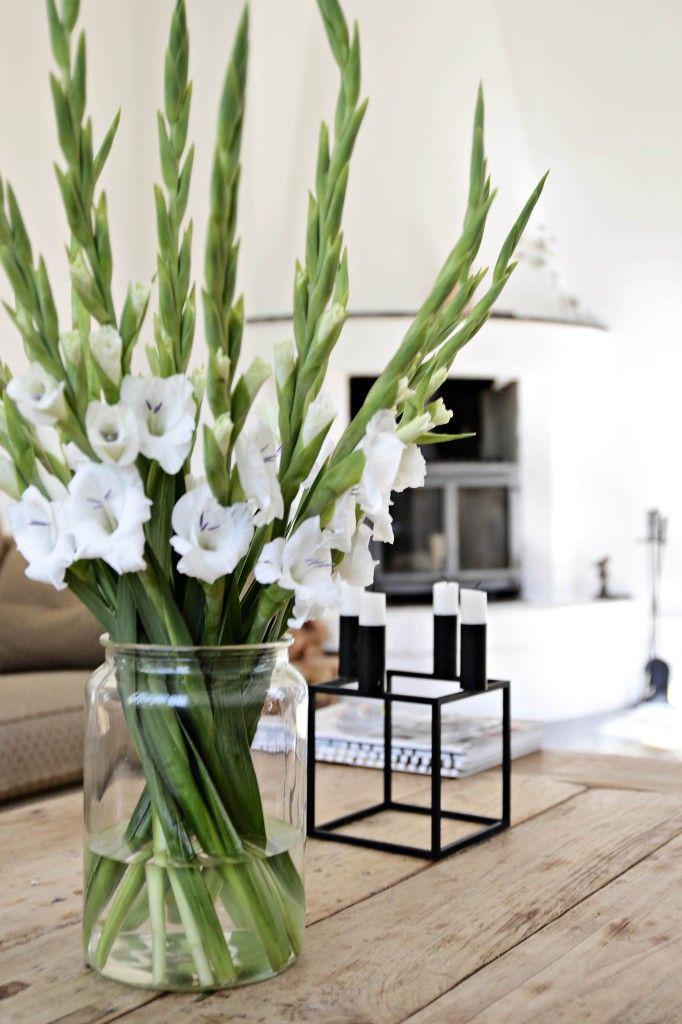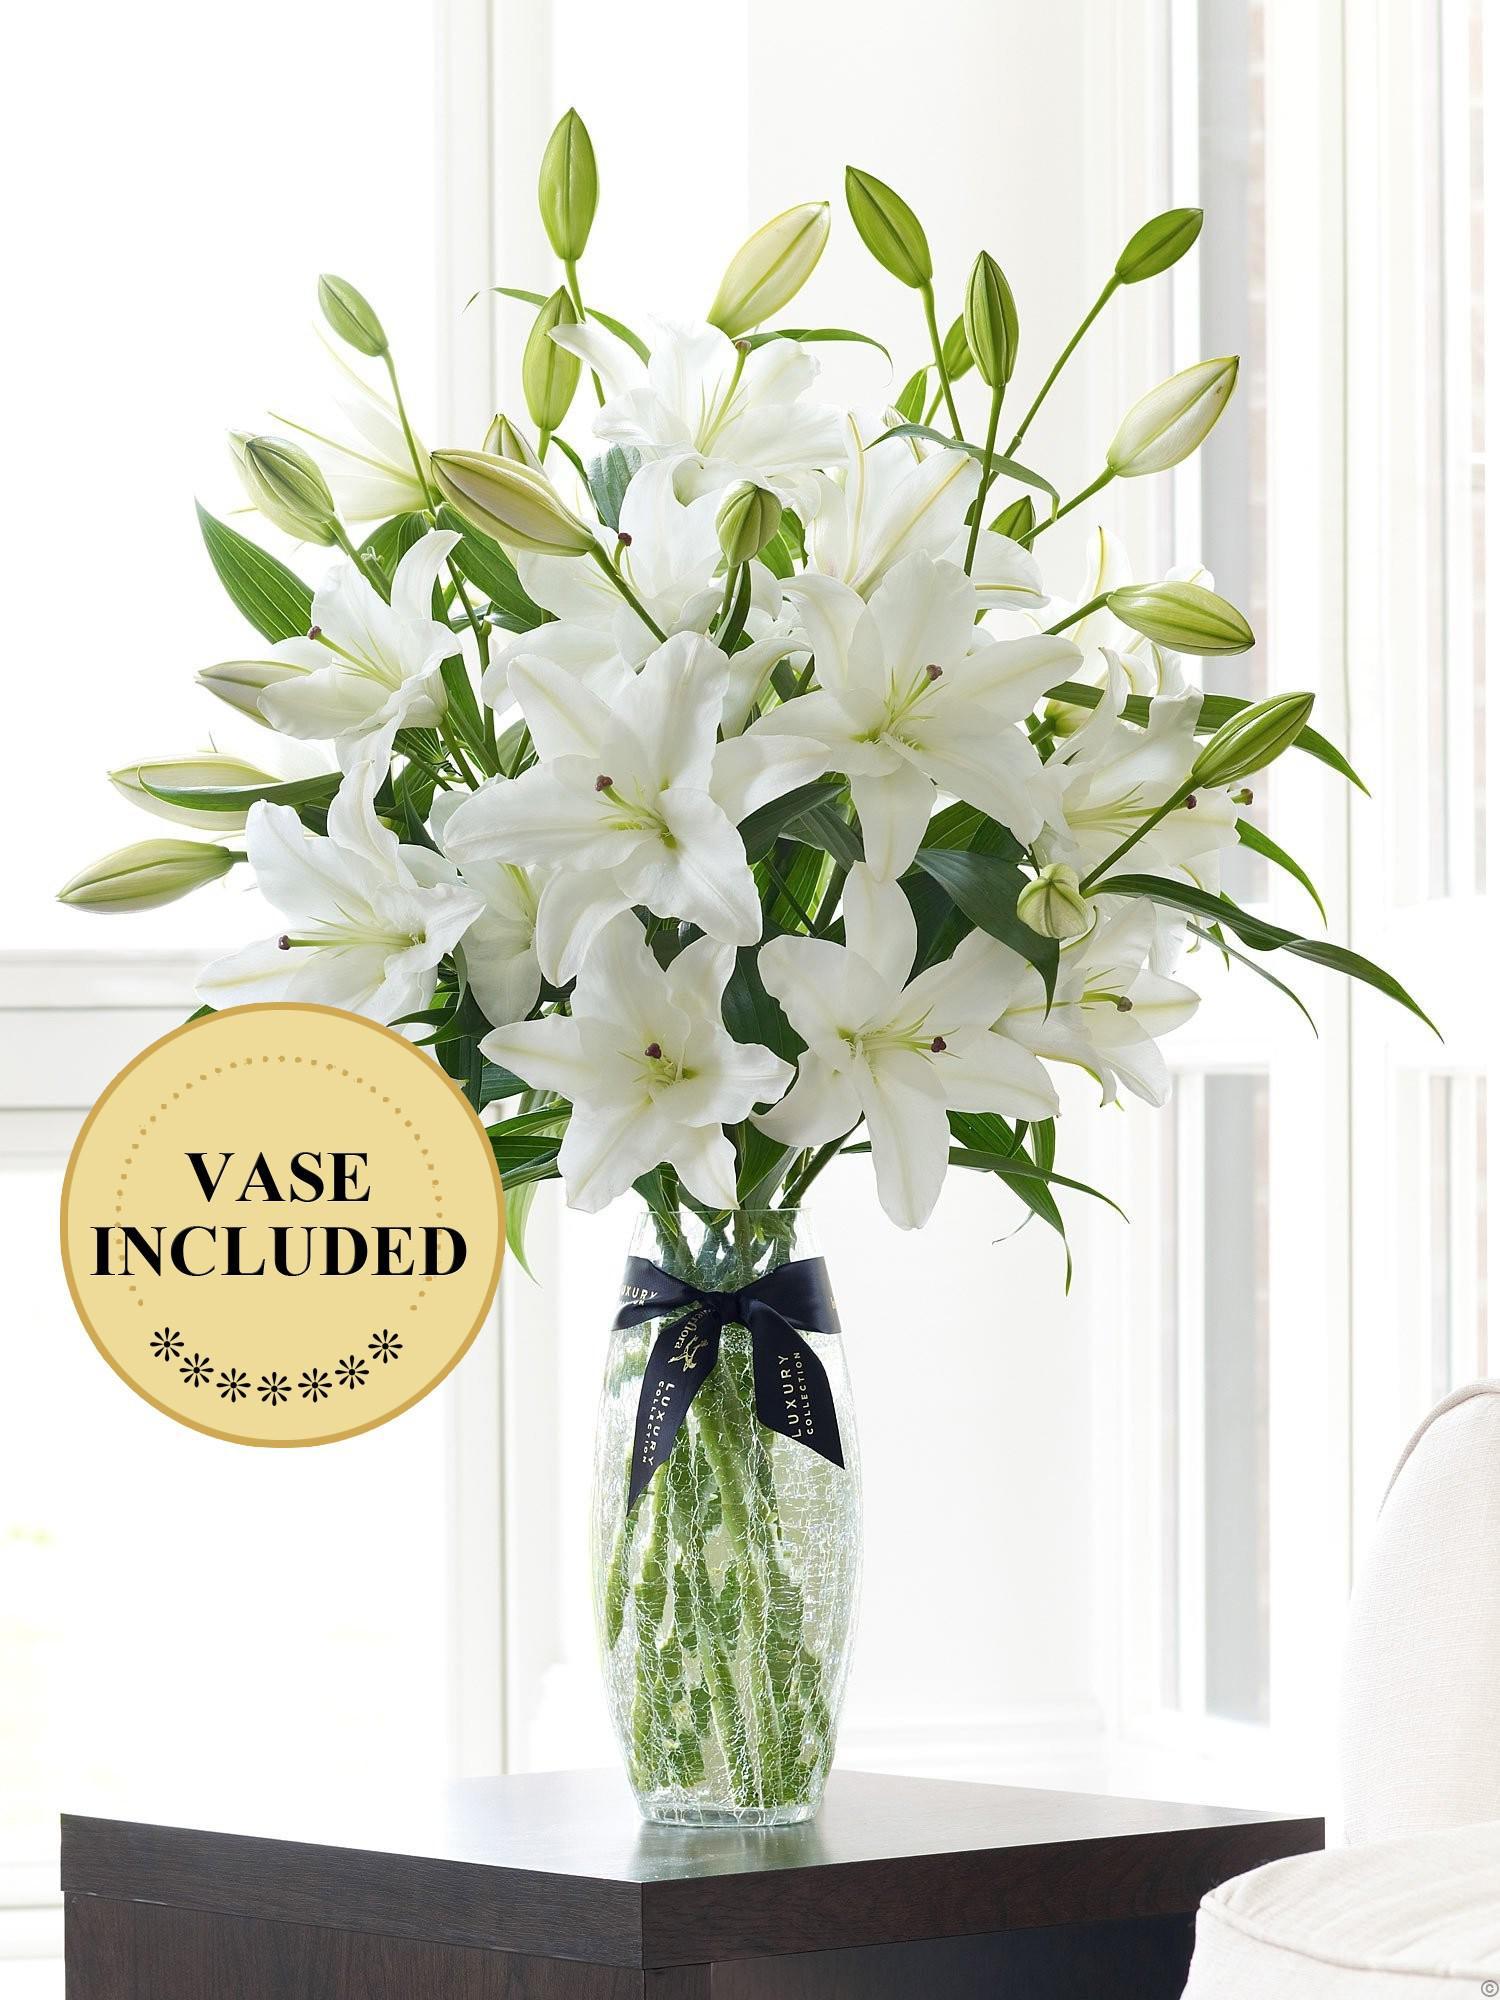The first image is the image on the left, the second image is the image on the right. For the images displayed, is the sentence "Curtains are visible in the background of the image on the left." factually correct? Answer yes or no. No. 